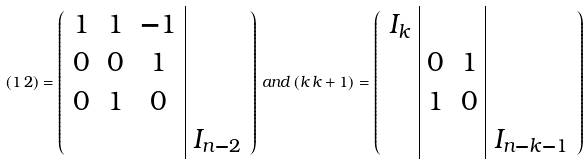<formula> <loc_0><loc_0><loc_500><loc_500>( 1 \, 2 ) = \left ( \begin{array} { c c c | c } 1 & 1 & - 1 & \\ 0 & 0 & 1 & \\ 0 & 1 & 0 & \\ & & & I _ { n - 2 } \end{array} \right ) \, a n d \, ( k \, k + 1 ) = \left ( \begin{array} { c | c c | c } I _ { k } & & & \\ & 0 & 1 & \\ & 1 & 0 & \\ & & & I _ { n - k - 1 } \end{array} \right )</formula> 